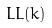Convert formula to latex. <formula><loc_0><loc_0><loc_500><loc_500>L L ( k )</formula> 